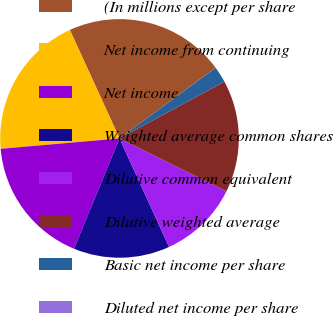Convert chart. <chart><loc_0><loc_0><loc_500><loc_500><pie_chart><fcel>(In millions except per share<fcel>Net income from continuing<fcel>Net income<fcel>Weighted average common shares<fcel>Dilutive common equivalent<fcel>Dilutive weighted average<fcel>Basic net income per share<fcel>Diluted net income per share<nl><fcel>21.73%<fcel>19.56%<fcel>17.39%<fcel>13.04%<fcel>10.87%<fcel>15.21%<fcel>2.19%<fcel>0.01%<nl></chart> 